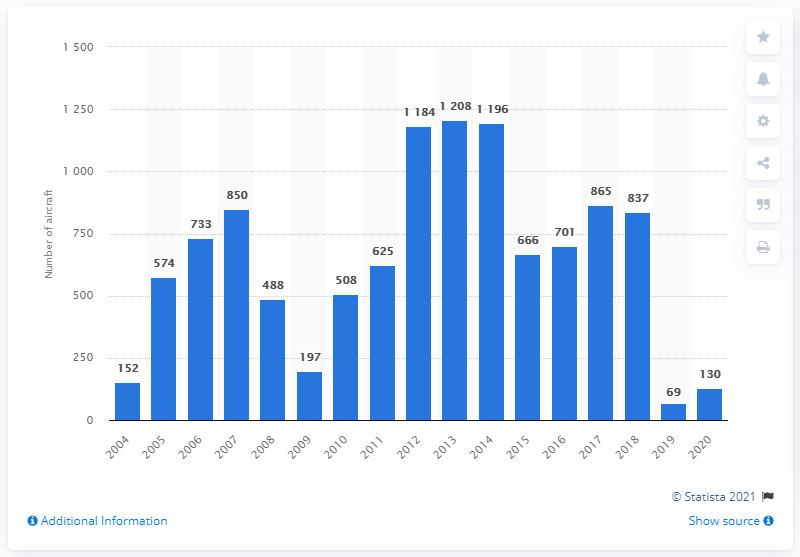Indicate a few pertinent items in this graphic. In 2020, Boeing received 130 units of its 737 narrow-body jet airliner series. 